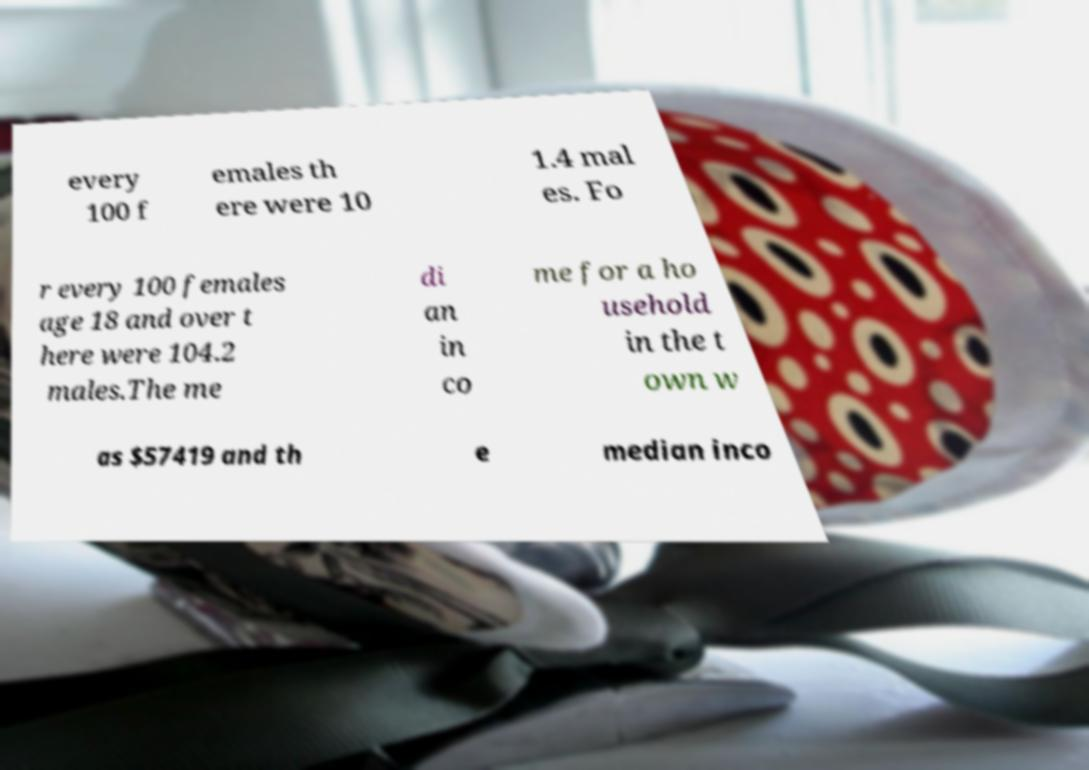Can you accurately transcribe the text from the provided image for me? every 100 f emales th ere were 10 1.4 mal es. Fo r every 100 females age 18 and over t here were 104.2 males.The me di an in co me for a ho usehold in the t own w as $57419 and th e median inco 